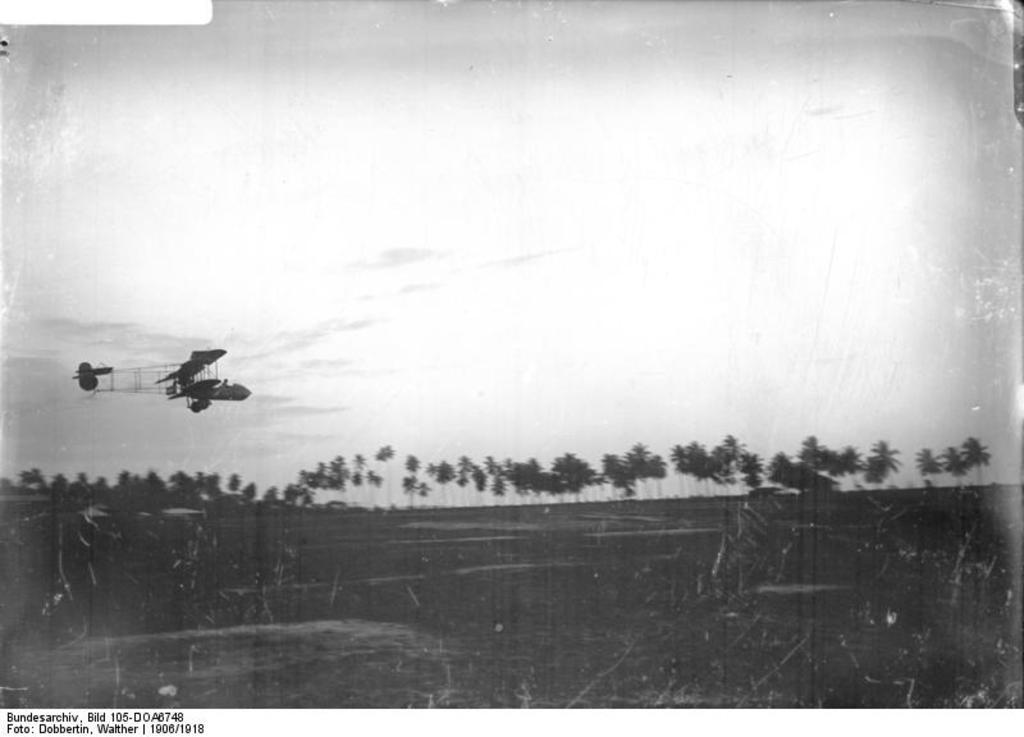Can you describe this image briefly? In this image I can see trees and background I can see sky and the image is in black and white. 